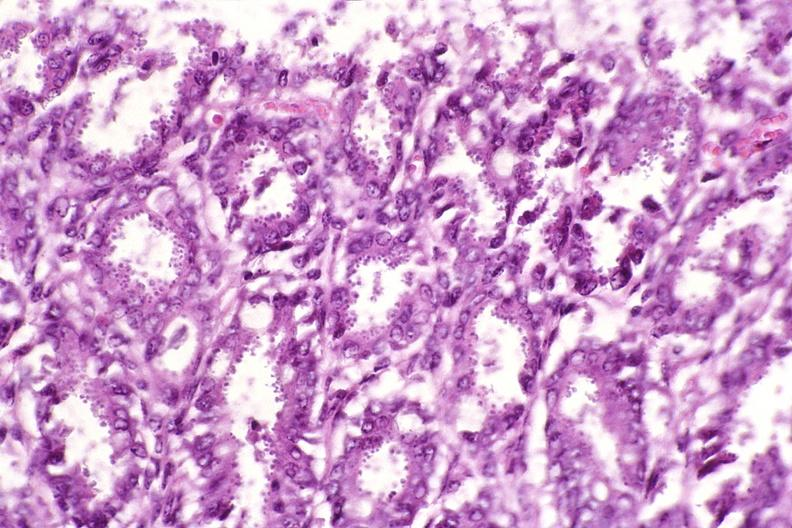what does this image show?
Answer the question using a single word or phrase. Colon 